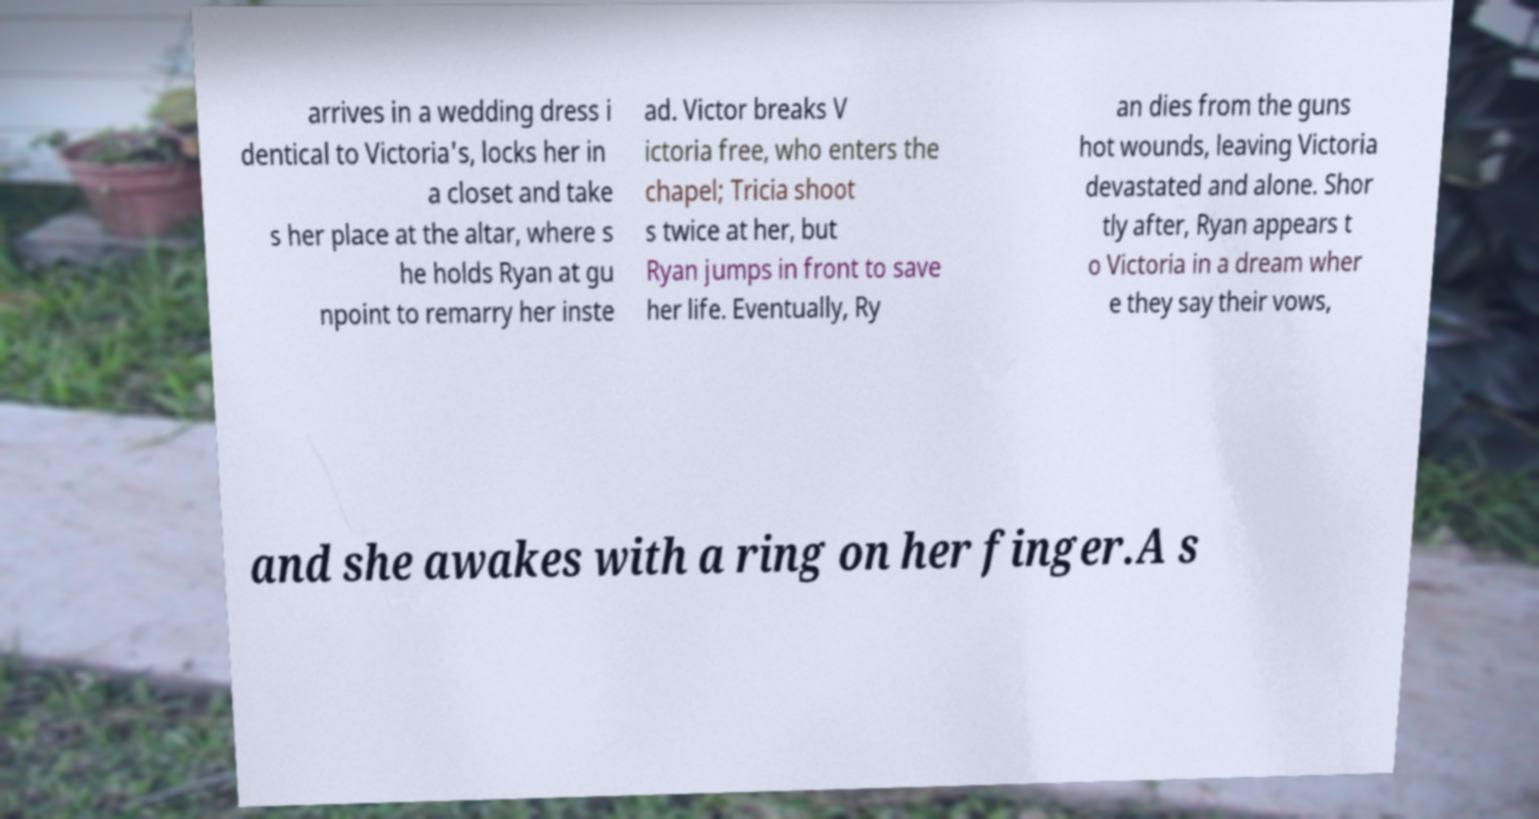Please identify and transcribe the text found in this image. arrives in a wedding dress i dentical to Victoria's, locks her in a closet and take s her place at the altar, where s he holds Ryan at gu npoint to remarry her inste ad. Victor breaks V ictoria free, who enters the chapel; Tricia shoot s twice at her, but Ryan jumps in front to save her life. Eventually, Ry an dies from the guns hot wounds, leaving Victoria devastated and alone. Shor tly after, Ryan appears t o Victoria in a dream wher e they say their vows, and she awakes with a ring on her finger.A s 